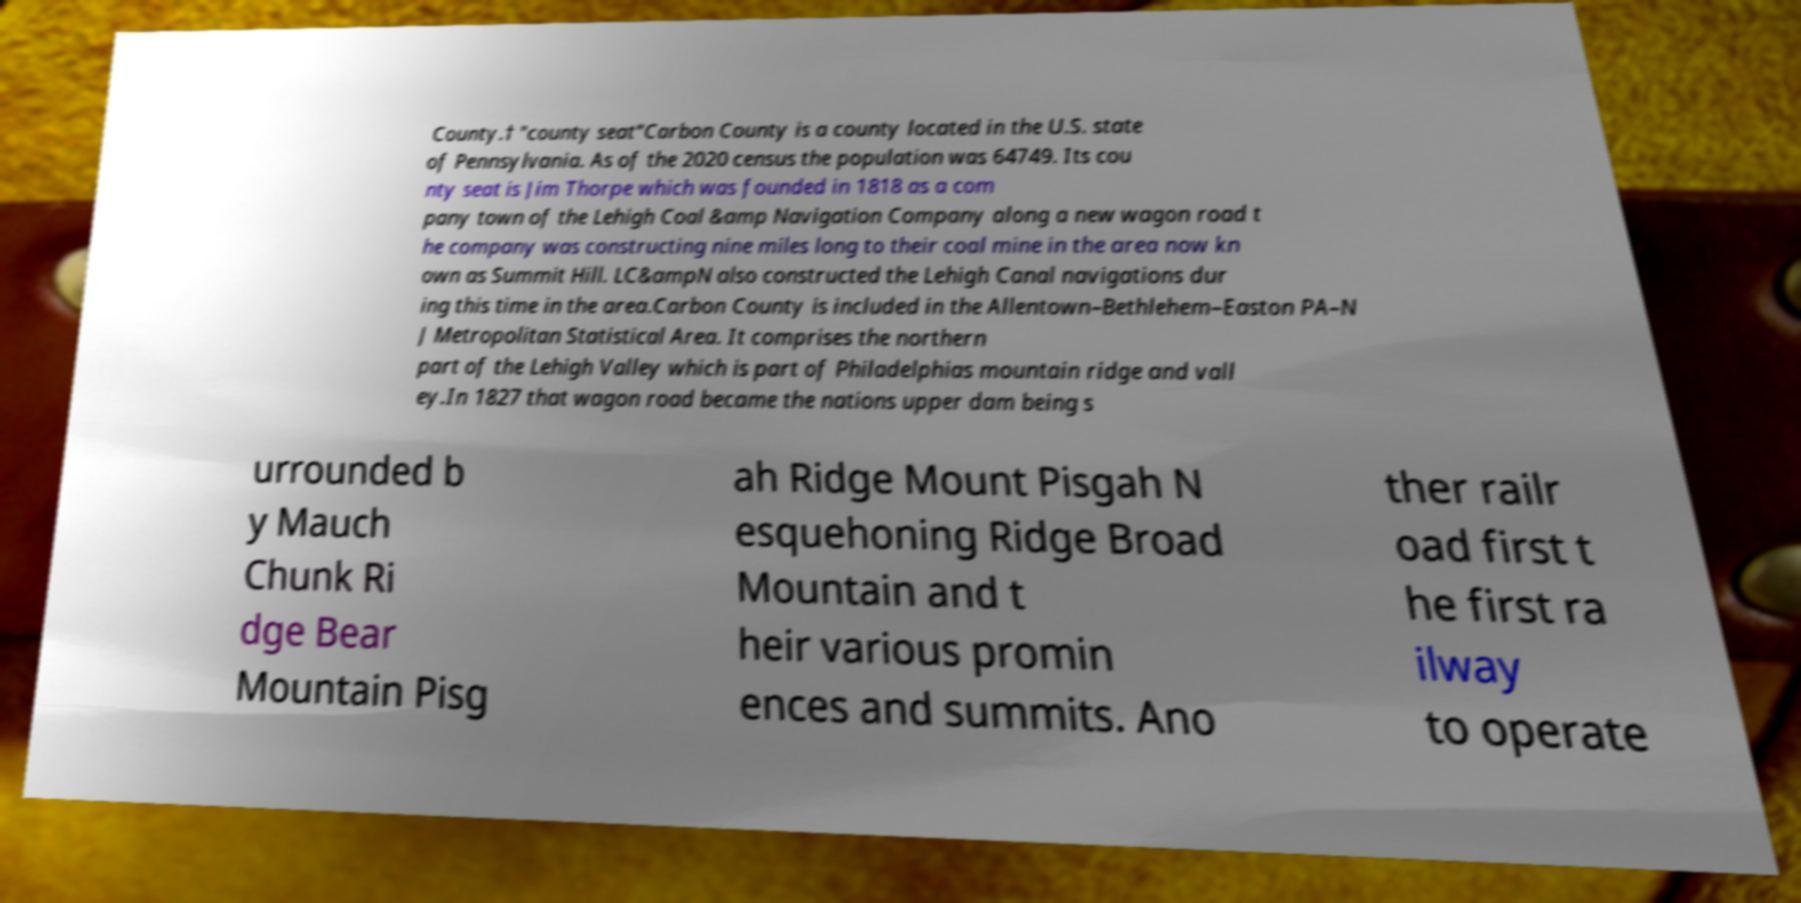For documentation purposes, I need the text within this image transcribed. Could you provide that? County.† "county seat"Carbon County is a county located in the U.S. state of Pennsylvania. As of the 2020 census the population was 64749. Its cou nty seat is Jim Thorpe which was founded in 1818 as a com pany town of the Lehigh Coal &amp Navigation Company along a new wagon road t he company was constructing nine miles long to their coal mine in the area now kn own as Summit Hill. LC&ampN also constructed the Lehigh Canal navigations dur ing this time in the area.Carbon County is included in the Allentown–Bethlehem–Easton PA–N J Metropolitan Statistical Area. It comprises the northern part of the Lehigh Valley which is part of Philadelphias mountain ridge and vall ey.In 1827 that wagon road became the nations upper dam being s urrounded b y Mauch Chunk Ri dge Bear Mountain Pisg ah Ridge Mount Pisgah N esquehoning Ridge Broad Mountain and t heir various promin ences and summits. Ano ther railr oad first t he first ra ilway to operate 